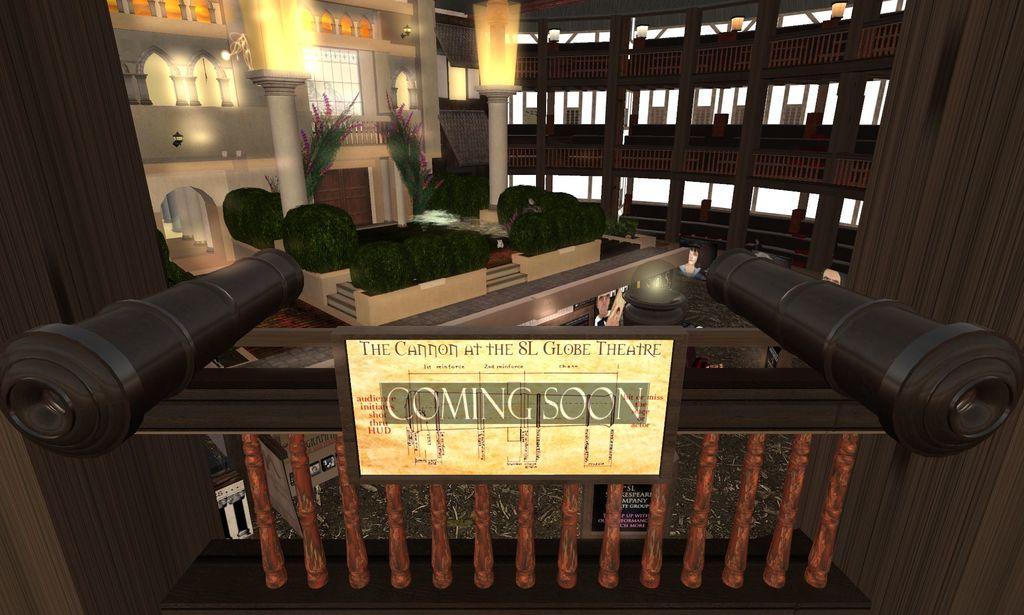In one or two sentences, can you explain what this image depicts? This is an animated image where we can see the board on which we can see some text, here I can see some objects, railing, shrubs, pillars and lights in the background. 